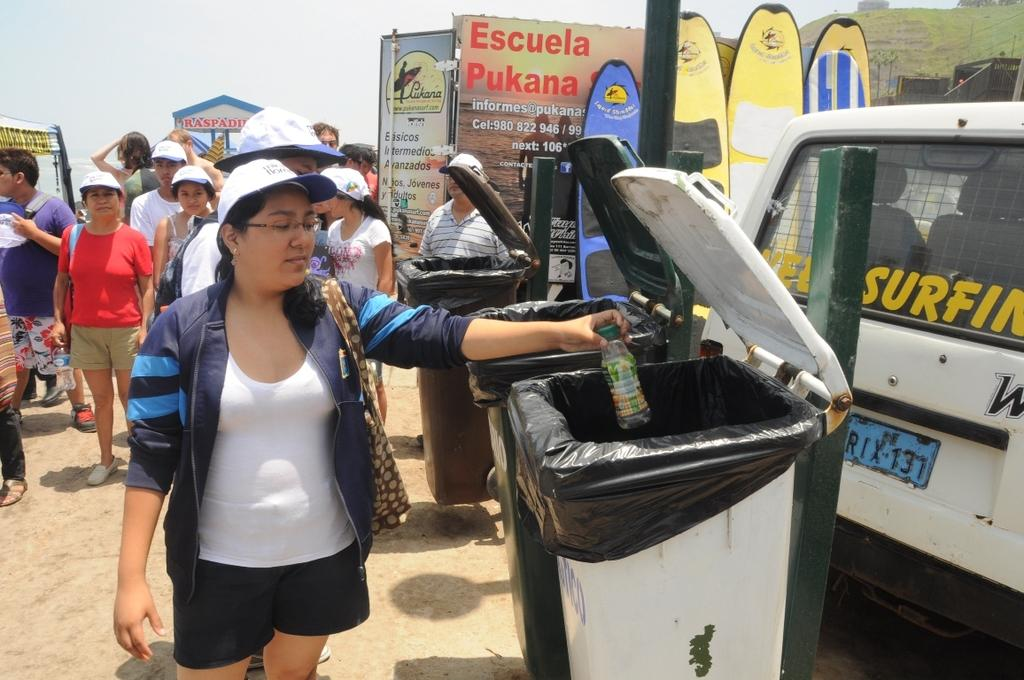Provide a one-sentence caption for the provided image. A woman throwing away a bottle at a Surfing event. 